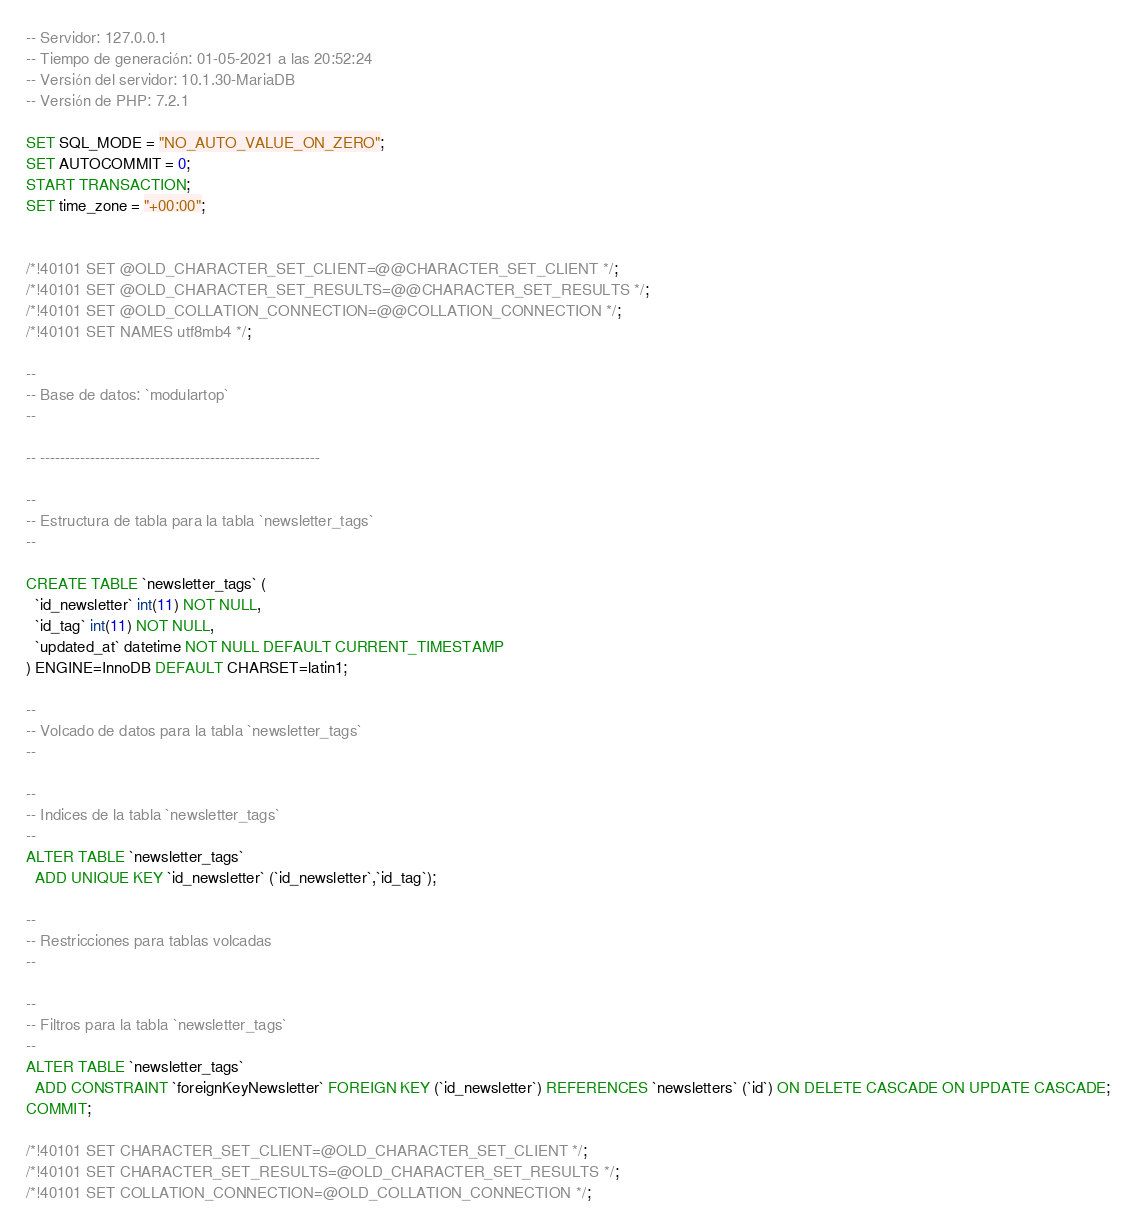<code> <loc_0><loc_0><loc_500><loc_500><_SQL_>-- Servidor: 127.0.0.1
-- Tiempo de generación: 01-05-2021 a las 20:52:24
-- Versión del servidor: 10.1.30-MariaDB
-- Versión de PHP: 7.2.1

SET SQL_MODE = "NO_AUTO_VALUE_ON_ZERO";
SET AUTOCOMMIT = 0;
START TRANSACTION;
SET time_zone = "+00:00";


/*!40101 SET @OLD_CHARACTER_SET_CLIENT=@@CHARACTER_SET_CLIENT */;
/*!40101 SET @OLD_CHARACTER_SET_RESULTS=@@CHARACTER_SET_RESULTS */;
/*!40101 SET @OLD_COLLATION_CONNECTION=@@COLLATION_CONNECTION */;
/*!40101 SET NAMES utf8mb4 */;

--
-- Base de datos: `modulartop`
--

-- --------------------------------------------------------

--
-- Estructura de tabla para la tabla `newsletter_tags`
--

CREATE TABLE `newsletter_tags` (
  `id_newsletter` int(11) NOT NULL,
  `id_tag` int(11) NOT NULL,
  `updated_at` datetime NOT NULL DEFAULT CURRENT_TIMESTAMP
) ENGINE=InnoDB DEFAULT CHARSET=latin1;

--
-- Volcado de datos para la tabla `newsletter_tags`
--

--
-- Indices de la tabla `newsletter_tags`
--
ALTER TABLE `newsletter_tags`
  ADD UNIQUE KEY `id_newsletter` (`id_newsletter`,`id_tag`);

--
-- Restricciones para tablas volcadas
--

--
-- Filtros para la tabla `newsletter_tags`
--
ALTER TABLE `newsletter_tags`
  ADD CONSTRAINT `foreignKeyNewsletter` FOREIGN KEY (`id_newsletter`) REFERENCES `newsletters` (`id`) ON DELETE CASCADE ON UPDATE CASCADE;
COMMIT;

/*!40101 SET CHARACTER_SET_CLIENT=@OLD_CHARACTER_SET_CLIENT */;
/*!40101 SET CHARACTER_SET_RESULTS=@OLD_CHARACTER_SET_RESULTS */;
/*!40101 SET COLLATION_CONNECTION=@OLD_COLLATION_CONNECTION */;
</code> 